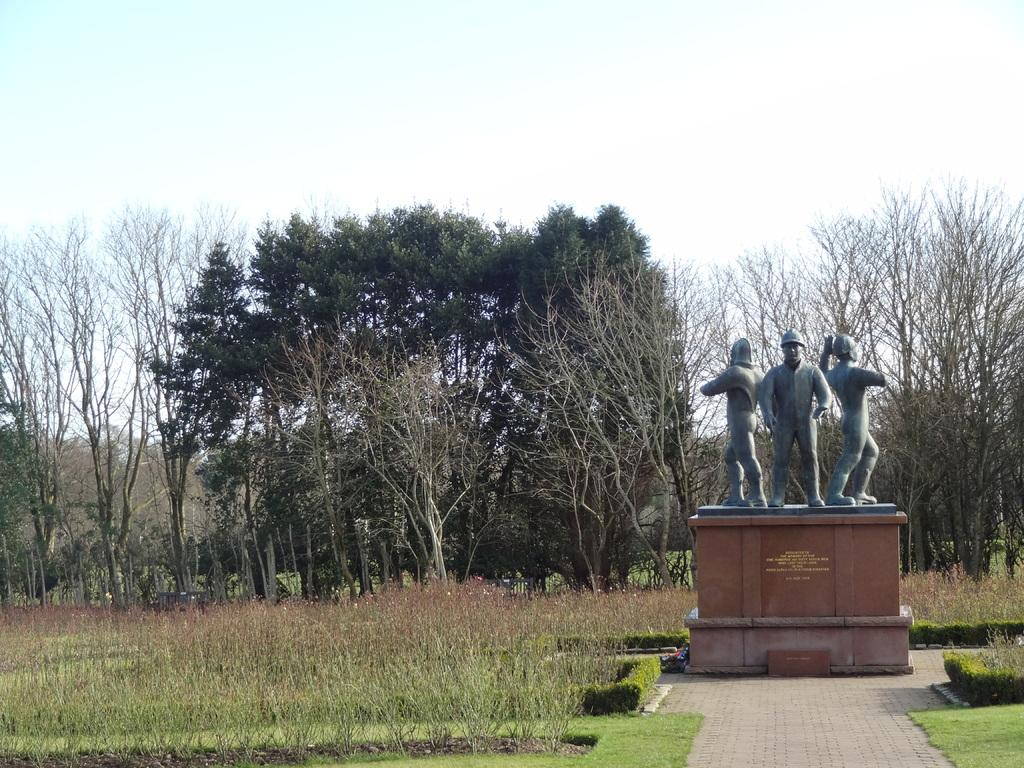What type of vegetation can be seen in the image? There are trees, plants, and grass in the image. What other objects or structures are present in the image? There is a statue in the image. What can be seen in the sky in the image? The sky is visible in the image. What type of curtain can be seen hanging from the trees in the image? There are no curtains present in the image; it features trees, plants, grass, a statue, and the sky. What songs are being sung by the plants in the image? Plants do not have the ability to sing songs, and there are no people or animals singing in the image. 